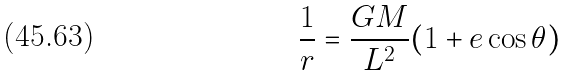Convert formula to latex. <formula><loc_0><loc_0><loc_500><loc_500>\frac { 1 } { r } = \frac { G M } { L ^ { 2 } } ( 1 + e \cos \theta )</formula> 